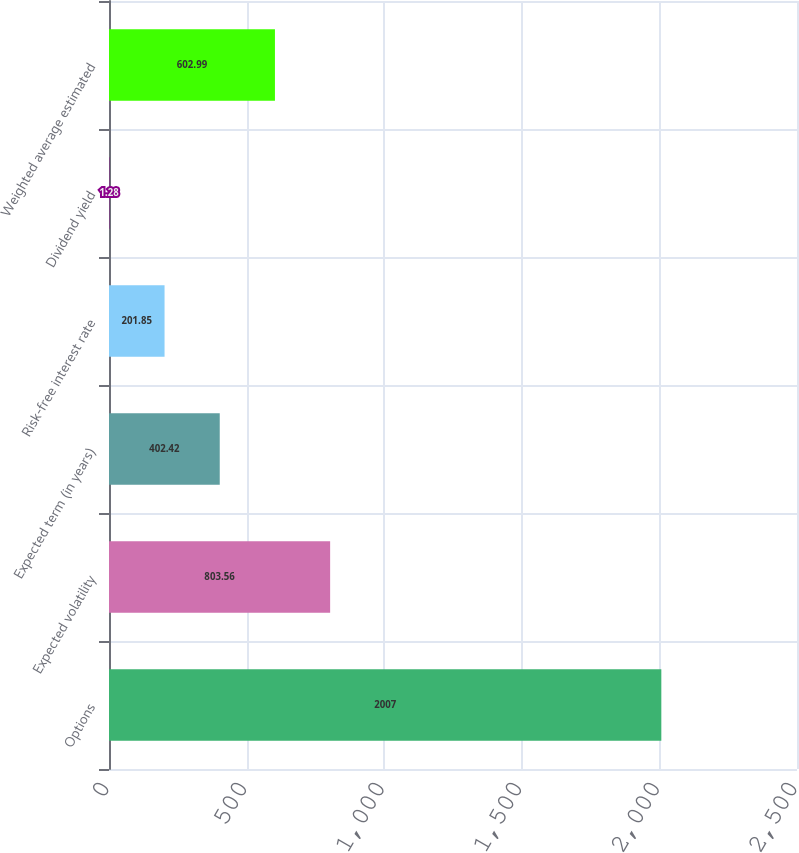Convert chart to OTSL. <chart><loc_0><loc_0><loc_500><loc_500><bar_chart><fcel>Options<fcel>Expected volatility<fcel>Expected term (in years)<fcel>Risk-free interest rate<fcel>Dividend yield<fcel>Weighted average estimated<nl><fcel>2007<fcel>803.56<fcel>402.42<fcel>201.85<fcel>1.28<fcel>602.99<nl></chart> 